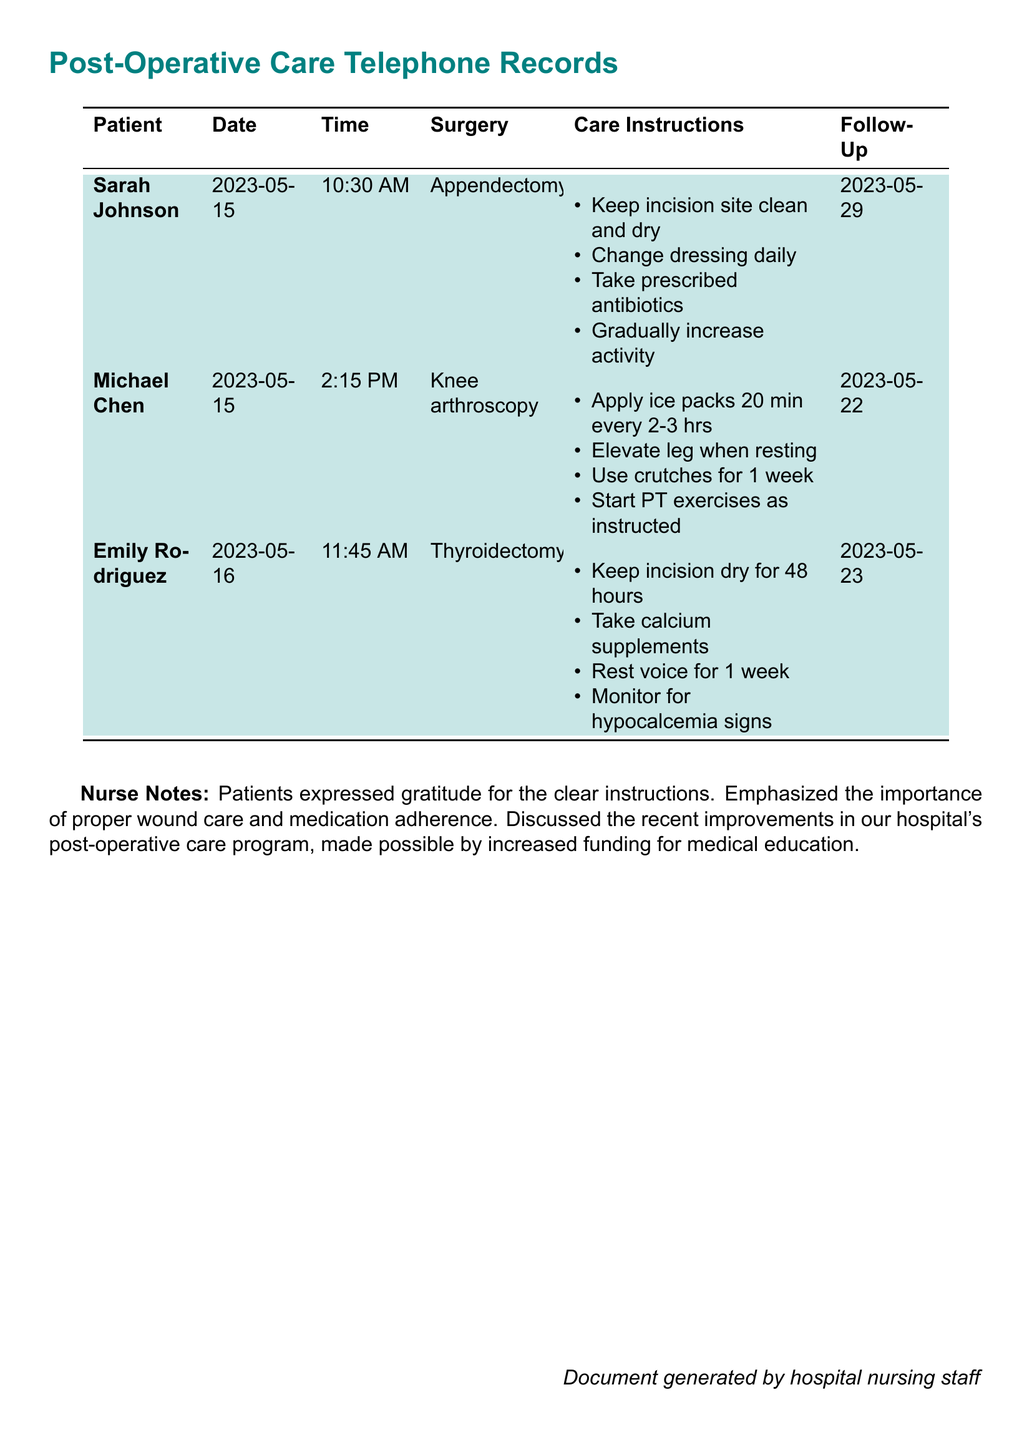What is the first patient's name? The first patient's name is listed in the document under the "Patient" column.
Answer: Sarah Johnson What surgery did Michael Chen have? The type of surgery Michael Chen had is indicated in the "Surgery" column next to his name.
Answer: Knee arthroscopy On what date did Emily Rodriguez have her phone consultation? The date of Emily Rodriguez's phone consultation can be found under the "Date" column.
Answer: 2023-05-16 How long should Sarah Johnson rest after her surgery? The care instructions detail activity resumption for Sarah Johnson in relation to her recovery.
Answer: Gradually increase activity When is the follow-up appointment for Michael Chen? The follow-up date for Michael Chen is stated in the "Follow-Up" column.
Answer: 2023-05-22 What care instruction is emphasized for Emily Rodriguez? The care instructions for Emily Rodriguez are outlined in the "Care Instructions" section.
Answer: Monitor for hypocalcemia signs What type of document is this? The document specifically records interactions with patients regarding their post-operative care.
Answer: Telephone records How many patients are discussed in this document? The number of patients is determined by counting the entries listed in the table.
Answer: Three 